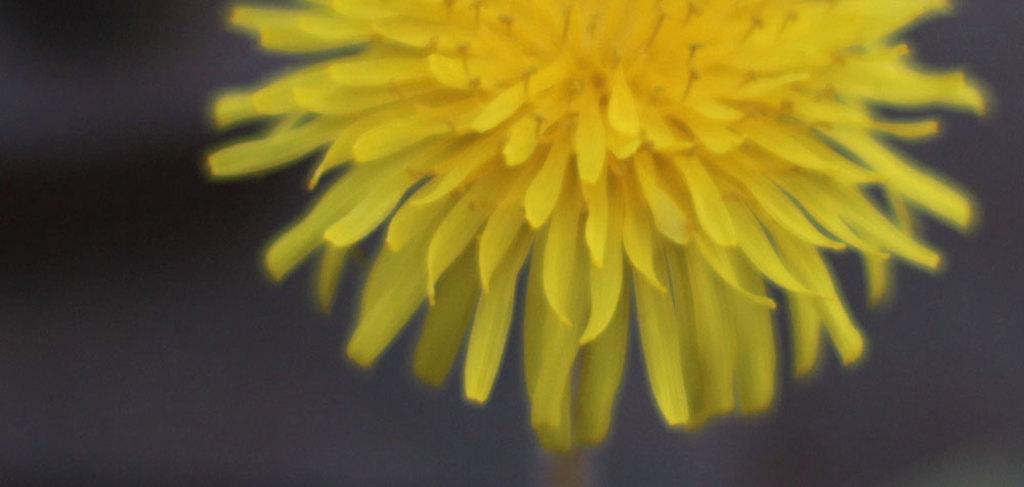What type of flower is present in the image? There is a yellow color flower in the image. What color is the background of the image? The background of the image is black. How many times does the person start to kick the ball in the image? There is no person or ball present in the image, so this action cannot be observed. 